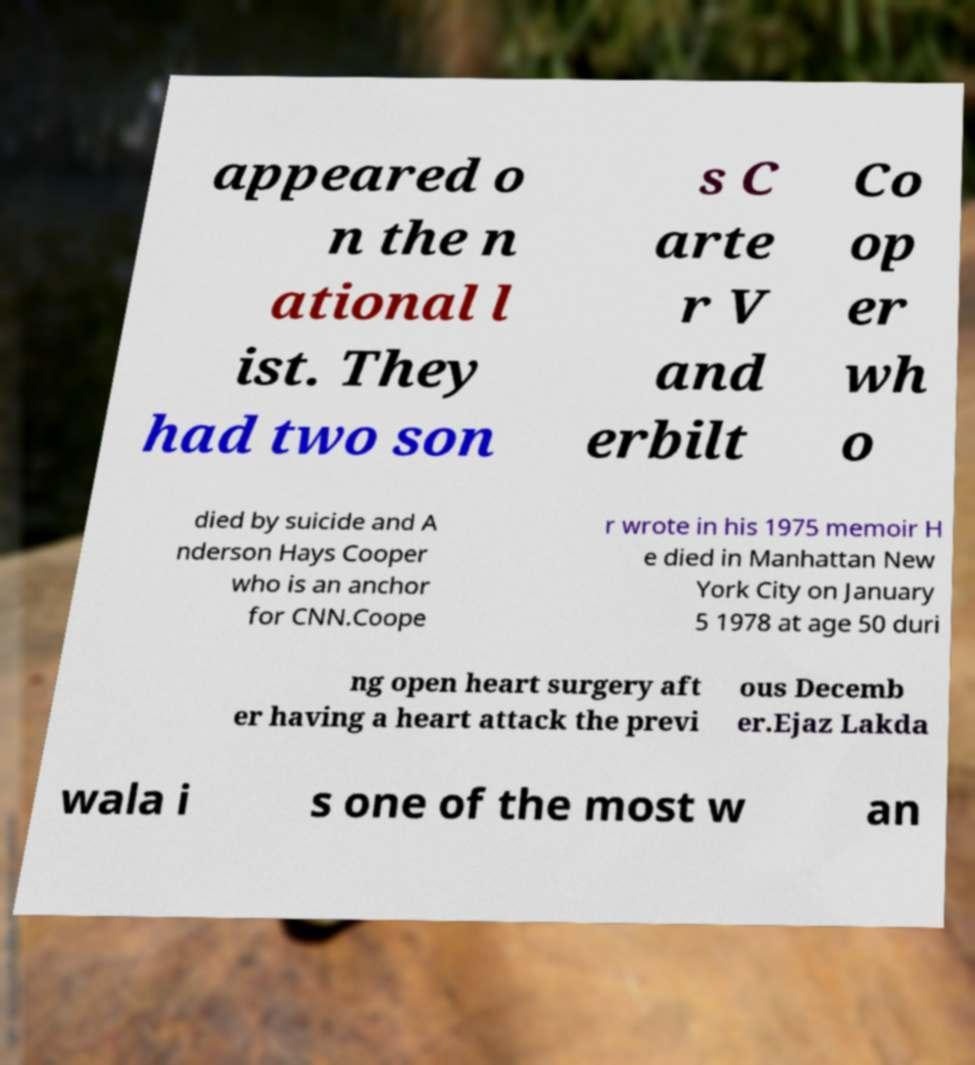Can you accurately transcribe the text from the provided image for me? appeared o n the n ational l ist. They had two son s C arte r V and erbilt Co op er wh o died by suicide and A nderson Hays Cooper who is an anchor for CNN.Coope r wrote in his 1975 memoir H e died in Manhattan New York City on January 5 1978 at age 50 duri ng open heart surgery aft er having a heart attack the previ ous Decemb er.Ejaz Lakda wala i s one of the most w an 